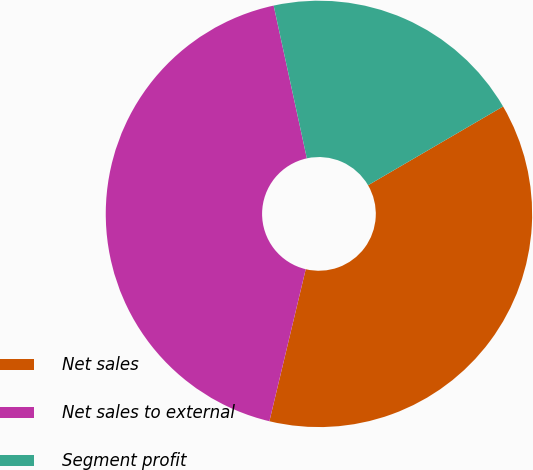Convert chart. <chart><loc_0><loc_0><loc_500><loc_500><pie_chart><fcel>Net sales<fcel>Net sales to external<fcel>Segment profit<nl><fcel>37.14%<fcel>42.86%<fcel>20.0%<nl></chart> 